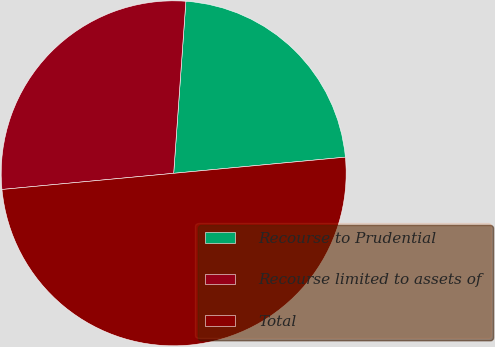<chart> <loc_0><loc_0><loc_500><loc_500><pie_chart><fcel>Recourse to Prudential<fcel>Recourse limited to assets of<fcel>Total<nl><fcel>22.38%<fcel>27.62%<fcel>50.0%<nl></chart> 